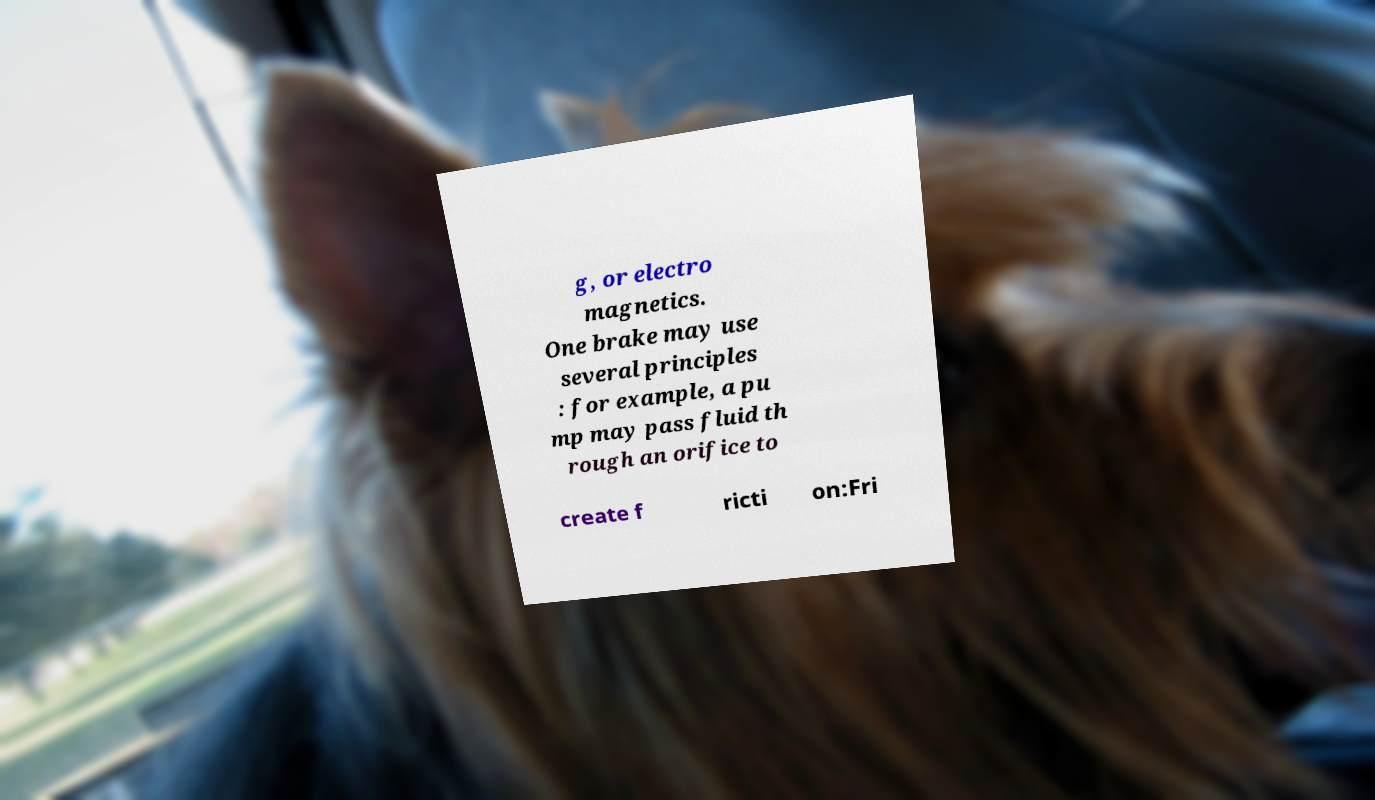Can you read and provide the text displayed in the image?This photo seems to have some interesting text. Can you extract and type it out for me? g, or electro magnetics. One brake may use several principles : for example, a pu mp may pass fluid th rough an orifice to create f ricti on:Fri 